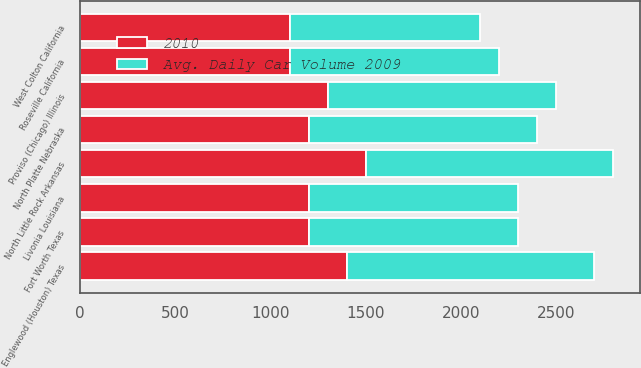<chart> <loc_0><loc_0><loc_500><loc_500><stacked_bar_chart><ecel><fcel>North Platte Nebraska<fcel>North Little Rock Arkansas<fcel>Englewood (Houston) Texas<fcel>Proviso (Chicago) Illinois<fcel>Fort Worth Texas<fcel>Livonia Louisiana<fcel>Roseville California<fcel>West Colton California<nl><fcel>2010<fcel>1200<fcel>1500<fcel>1400<fcel>1300<fcel>1200<fcel>1200<fcel>1100<fcel>1100<nl><fcel>Avg. Daily Car Volume 2009<fcel>1200<fcel>1300<fcel>1300<fcel>1200<fcel>1100<fcel>1100<fcel>1100<fcel>1000<nl></chart> 